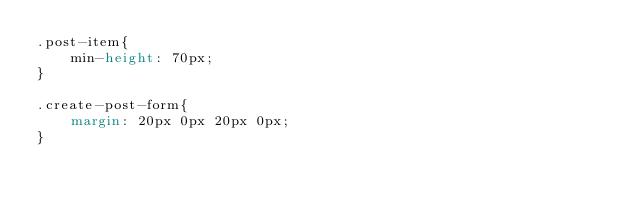<code> <loc_0><loc_0><loc_500><loc_500><_CSS_>.post-item{
    min-height: 70px;
}

.create-post-form{
    margin: 20px 0px 20px 0px;
}</code> 